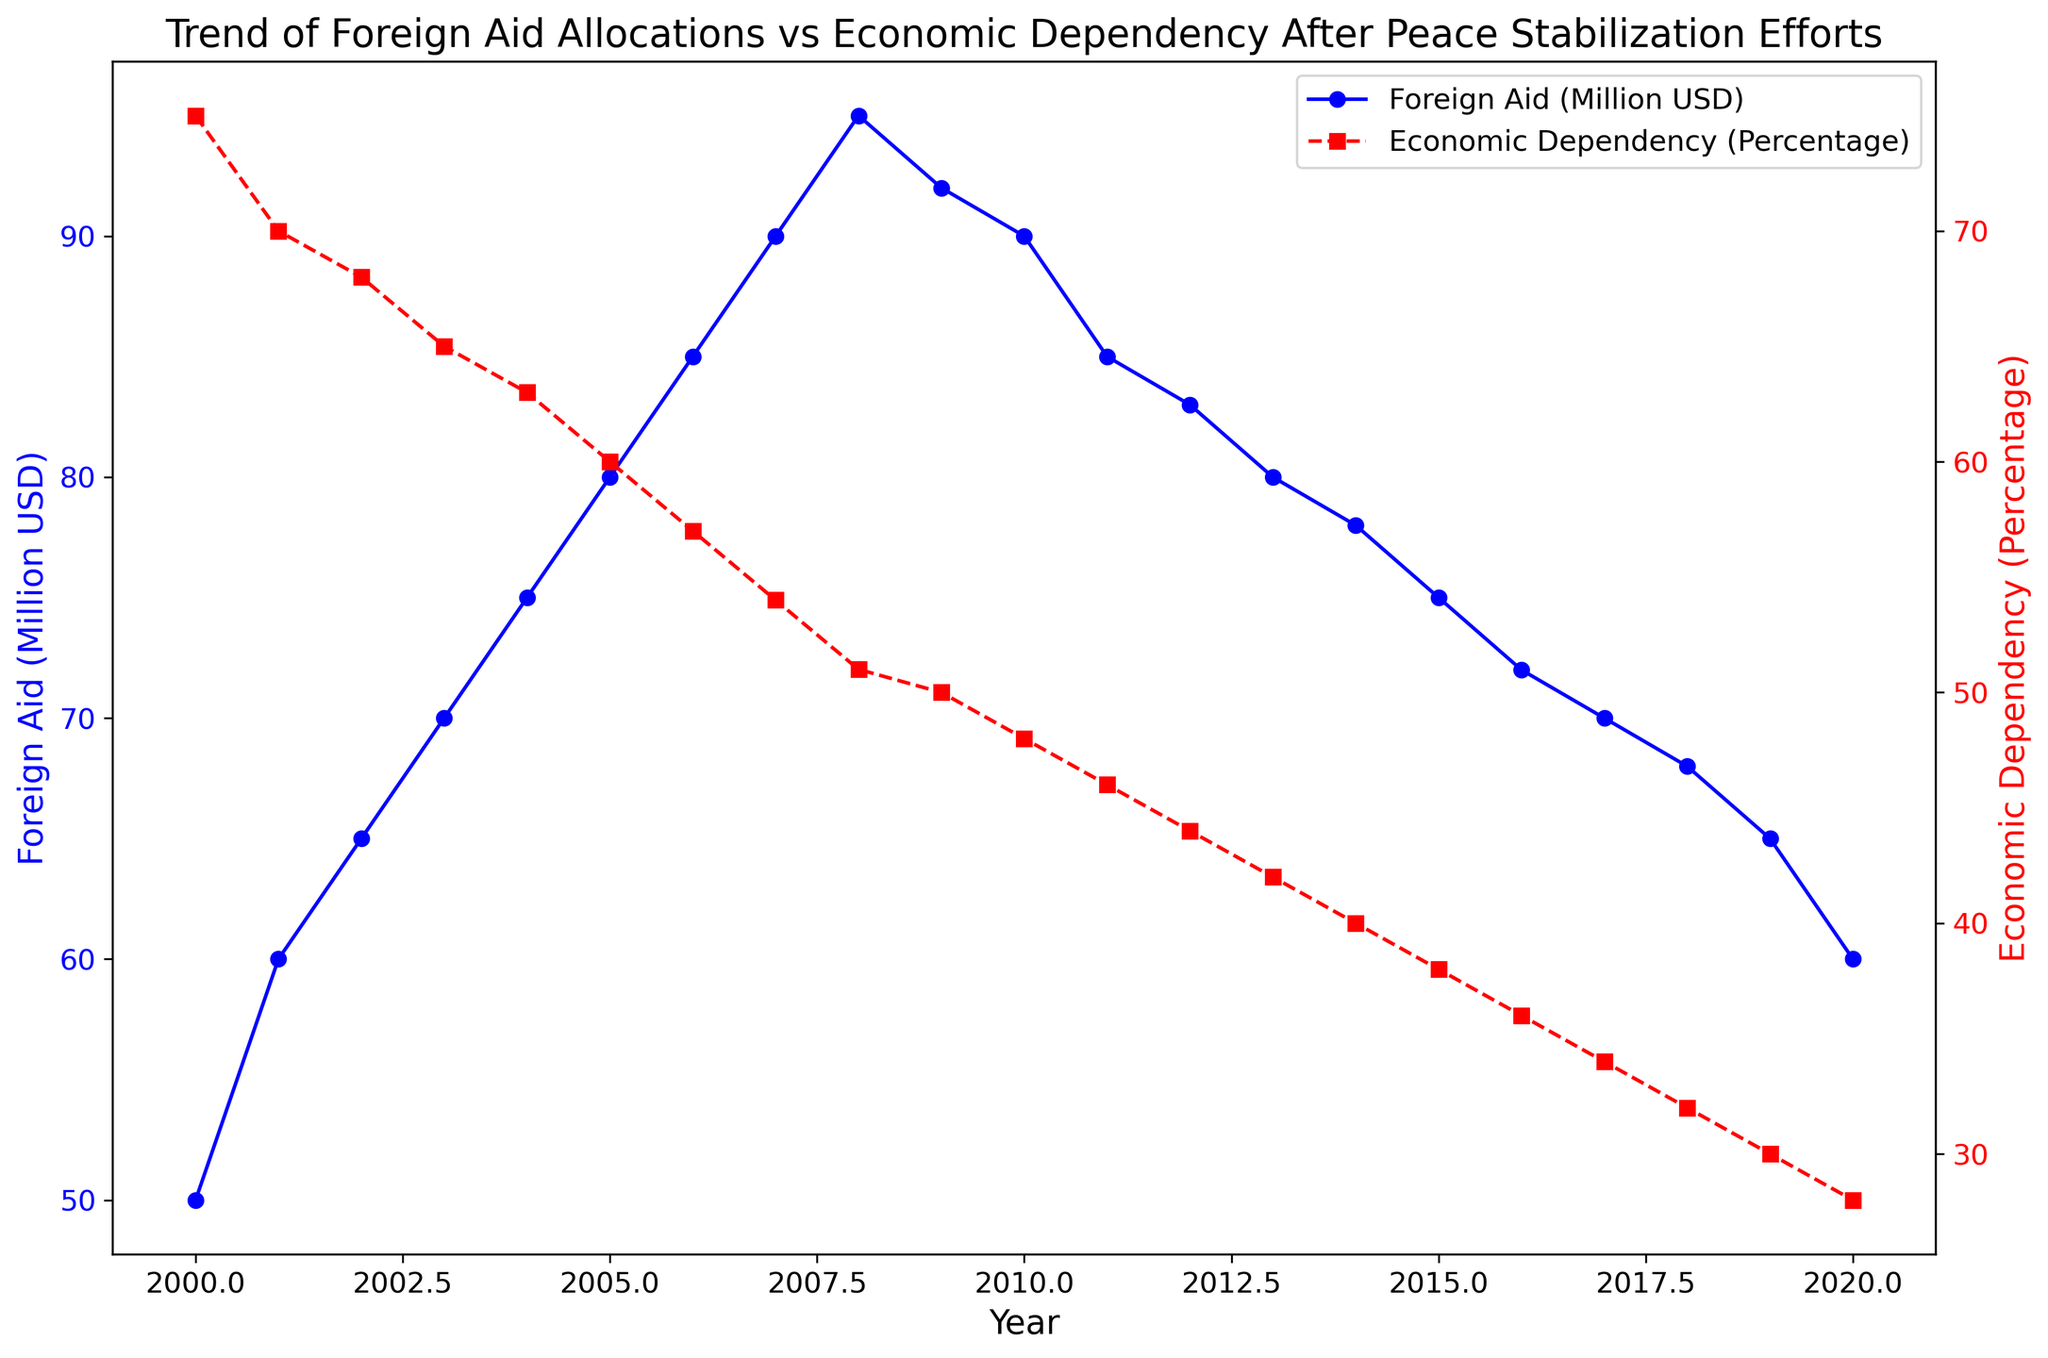What is the general trend of Foreign Aid from 2000 to 2020? The Foreign Aid generally increases from 50 million USD in 2000 to a peak of 95 million USD in 2008 and then decreases to 60 million USD in 2020.
Answer: The Foreign Aid generally increased then decreased How did Economic Dependency change from 2000 to 2020? Economic Dependency steadily decreased from 75% in 2000 to 28% in 2020.
Answer: Economic Dependency decreased Between which years did Foreign Aid reach its peak, and what was the value? Foreign Aid reached its peak between 2007 and 2008, at a value of 95 million USD.
Answer: 2007-2008, 95 million USD Did Foreign Aid and Economic Dependency always change in opposite directions? Mostly yes; Foreign Aid generally increased when Economic Dependency decreased, and vice versa. One exception is between 2008 and 2009 when both metrics decreased simultaneously.
Answer: Mostly yes, with an exception What was the decline in Foreign Aid between its peak in 2008 and the year 2014? The Foreign Aid decreased from 95 million USD in 2008 to 78 million USD in 2014. The decline is 95 - 78 = 17 million USD.
Answer: 17 million USD Which year saw the largest decrease in Economic Dependency, and what was the percentage drop? The largest decrease in Economic Dependency occurred from 2009 to 2010, dropping from 50% to 48%, which is a 2% decrease.
Answer: 2009-2010, 2% Compare the levels of Foreign Aid in 2000 and 2020. How much has it changed? Foreign Aid increased from 50 million USD in 2000 to 60 million USD in 2020, changing by 60 - 50 = 10 million USD.
Answer: 10 million USD What were the values of Foreign Aid and Economic Dependency in the year 2010? In 2010, Foreign Aid was 90 million USD, and Economic Dependency was 48%.
Answer: 90 million USD, 48% Between which two consecutive years did Foreign Aid decrease for the first time, and by how much did it decrease? Foreign Aid first decreased between 2008 and 2009, from 95 million USD to 92 million USD, a decrease of 95 - 92 = 3 million USD.
Answer: 2008-2009, 3 million USD Over the 20-year period, in which year did Economic Dependency reach approximately half of its initial value in 2000? Economic Dependency was approximately half of its 2000 value (75%) in 2012, at 44%.
Answer: 2012 